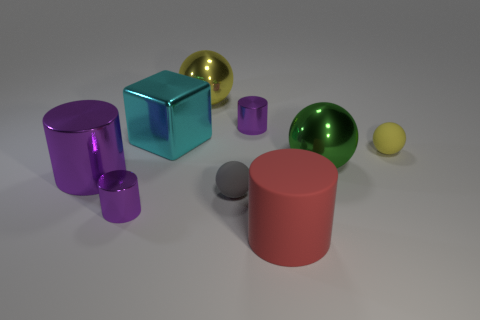Subtract all big yellow spheres. How many spheres are left? 3 Subtract all red cylinders. How many cylinders are left? 3 Subtract 1 balls. How many balls are left? 3 Subtract all gray cylinders. How many yellow balls are left? 2 Subtract all spheres. How many objects are left? 5 Subtract all yellow matte cubes. Subtract all tiny gray matte balls. How many objects are left? 8 Add 3 large things. How many large things are left? 8 Add 2 rubber cylinders. How many rubber cylinders exist? 3 Subtract 0 cyan cylinders. How many objects are left? 9 Subtract all purple cylinders. Subtract all brown balls. How many cylinders are left? 1 